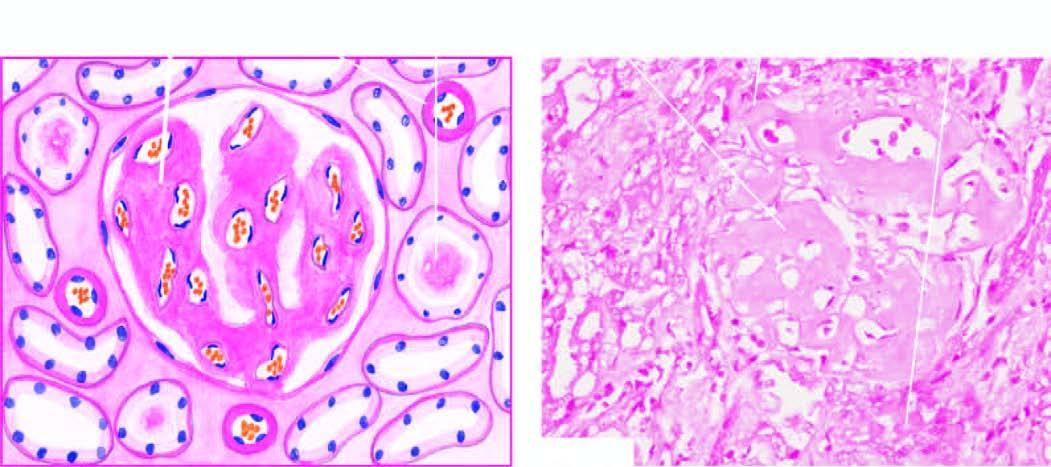what are seen mainly in the glomerular capillary tuft?
Answer the question using a single word or phrase. The amyloid deposits 